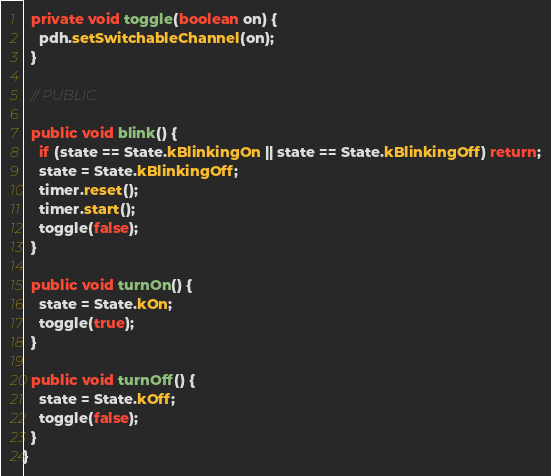Convert code to text. <code><loc_0><loc_0><loc_500><loc_500><_Java_>  private void toggle(boolean on) {
    pdh.setSwitchableChannel(on);
  }

  // PUBLIC

  public void blink() {
    if (state == State.kBlinkingOn || state == State.kBlinkingOff) return;
    state = State.kBlinkingOff;
    timer.reset();
    timer.start();
    toggle(false);
  }

  public void turnOn() {
    state = State.kOn;
    toggle(true);
  }

  public void turnOff() {
    state = State.kOff;
    toggle(false);
  }
}
</code> 